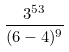<formula> <loc_0><loc_0><loc_500><loc_500>\frac { 3 ^ { 5 3 } } { ( 6 - 4 ) ^ { 9 } }</formula> 